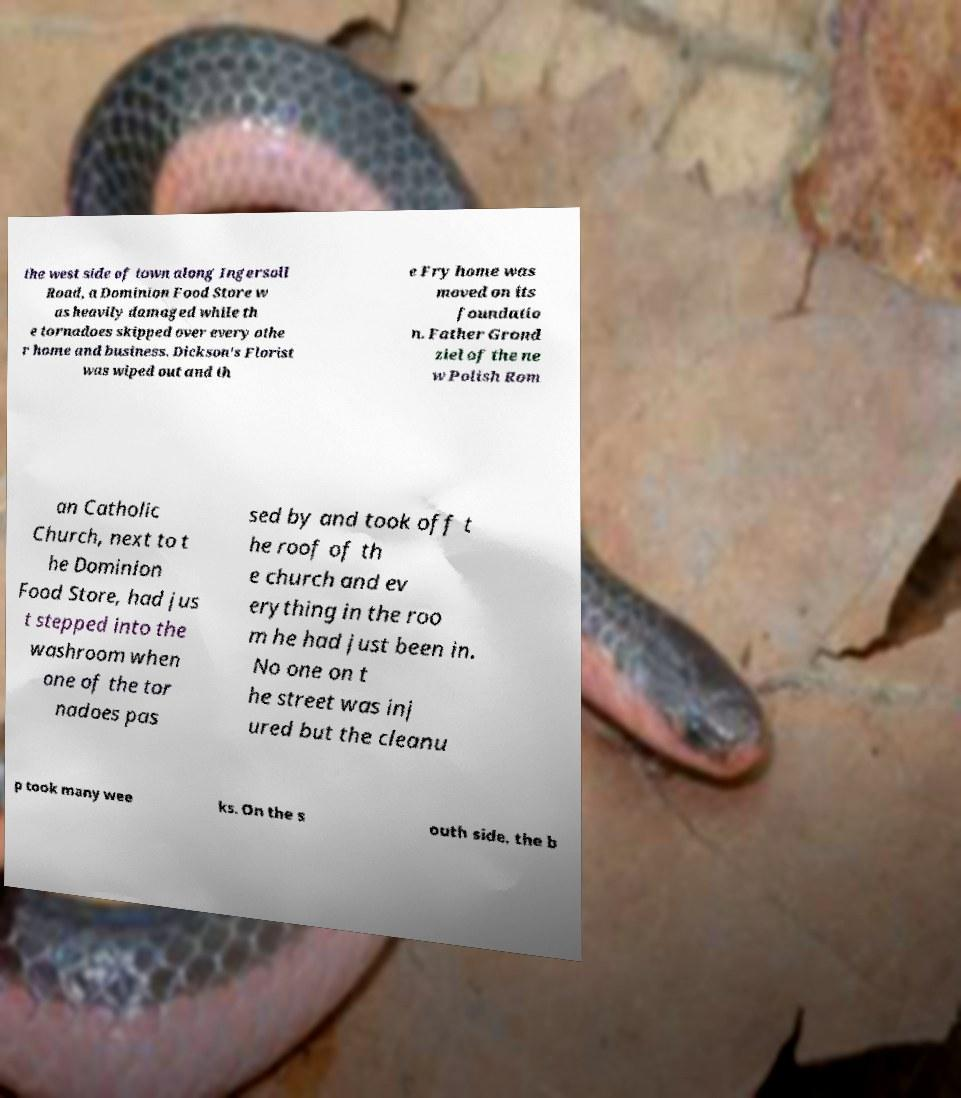Can you read and provide the text displayed in the image?This photo seems to have some interesting text. Can you extract and type it out for me? the west side of town along Ingersoll Road, a Dominion Food Store w as heavily damaged while th e tornadoes skipped over every othe r home and business. Dickson's Florist was wiped out and th e Fry home was moved on its foundatio n. Father Grond ziel of the ne w Polish Rom an Catholic Church, next to t he Dominion Food Store, had jus t stepped into the washroom when one of the tor nadoes pas sed by and took off t he roof of th e church and ev erything in the roo m he had just been in. No one on t he street was inj ured but the cleanu p took many wee ks. On the s outh side, the b 